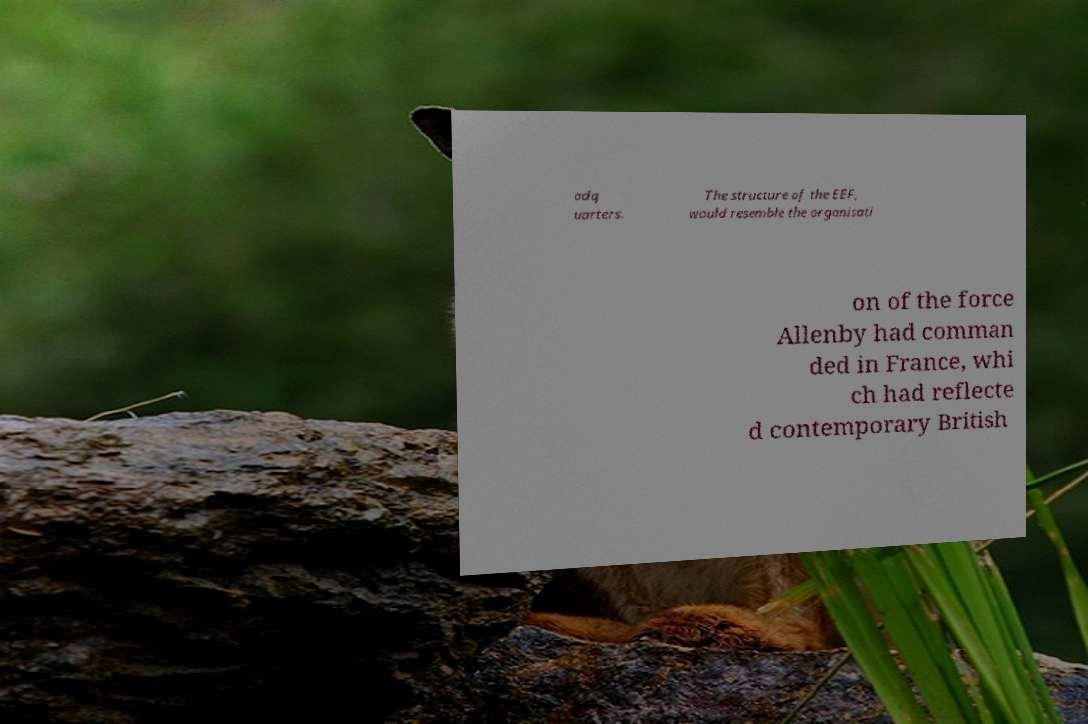For documentation purposes, I need the text within this image transcribed. Could you provide that? adq uarters. The structure of the EEF, would resemble the organisati on of the force Allenby had comman ded in France, whi ch had reflecte d contemporary British 